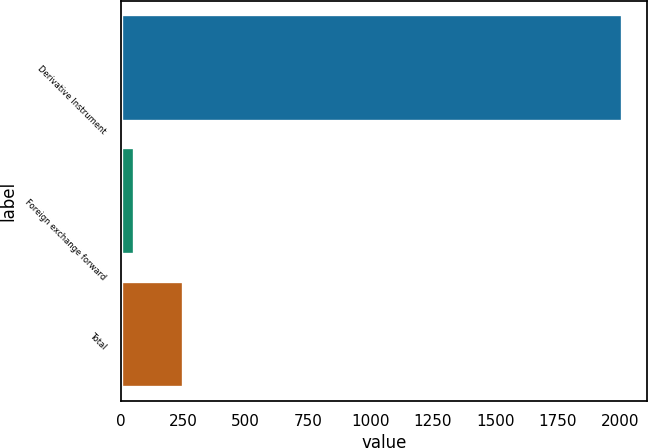Convert chart to OTSL. <chart><loc_0><loc_0><loc_500><loc_500><bar_chart><fcel>Derivative Instrument<fcel>Foreign exchange forward<fcel>Total<nl><fcel>2008<fcel>52.6<fcel>248.14<nl></chart> 